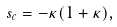<formula> <loc_0><loc_0><loc_500><loc_500>s _ { c } = - \kappa ( 1 + \kappa ) ,</formula> 